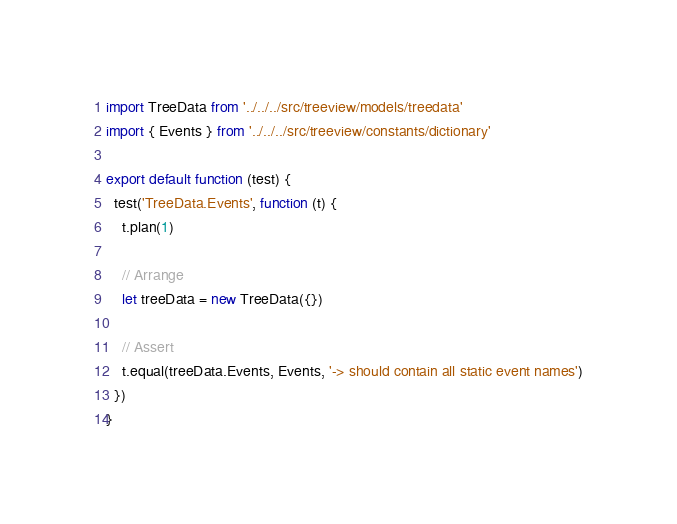<code> <loc_0><loc_0><loc_500><loc_500><_TypeScript_>import TreeData from '../../../src/treeview/models/treedata'
import { Events } from '../../../src/treeview/constants/dictionary'

export default function (test) {
  test('TreeData.Events', function (t) {
    t.plan(1)

    // Arrange
    let treeData = new TreeData({})

    // Assert
    t.equal(treeData.Events, Events, '-> should contain all static event names')
  })
}
</code> 